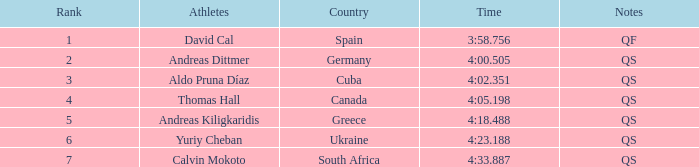What is the ranking of andreas kiligkaridis? 5.0. 